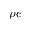<formula> <loc_0><loc_0><loc_500><loc_500>\rho e</formula> 